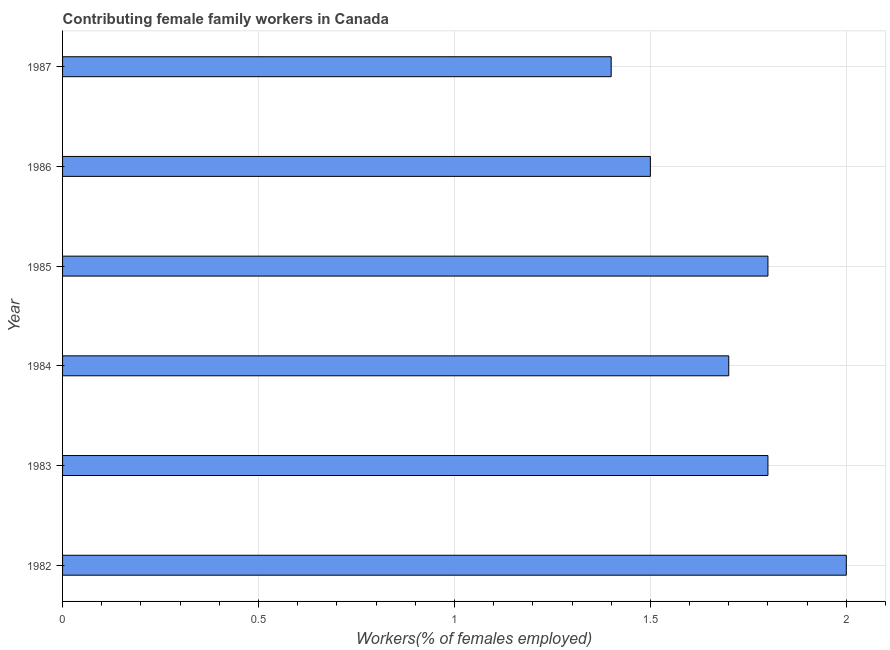Does the graph contain any zero values?
Your answer should be compact. No. What is the title of the graph?
Offer a very short reply. Contributing female family workers in Canada. What is the label or title of the X-axis?
Your answer should be compact. Workers(% of females employed). What is the contributing female family workers in 1983?
Your answer should be very brief. 1.8. Across all years, what is the maximum contributing female family workers?
Your answer should be compact. 2. Across all years, what is the minimum contributing female family workers?
Make the answer very short. 1.4. In which year was the contributing female family workers maximum?
Your answer should be compact. 1982. What is the sum of the contributing female family workers?
Ensure brevity in your answer.  10.2. What is the average contributing female family workers per year?
Offer a very short reply. 1.7. In how many years, is the contributing female family workers greater than 0.1 %?
Make the answer very short. 6. Do a majority of the years between 1984 and 1985 (inclusive) have contributing female family workers greater than 0.5 %?
Offer a terse response. Yes. What is the ratio of the contributing female family workers in 1982 to that in 1984?
Offer a terse response. 1.18. What is the difference between the highest and the second highest contributing female family workers?
Provide a short and direct response. 0.2. In how many years, is the contributing female family workers greater than the average contributing female family workers taken over all years?
Provide a short and direct response. 4. How many bars are there?
Your answer should be very brief. 6. What is the Workers(% of females employed) of 1982?
Your answer should be compact. 2. What is the Workers(% of females employed) in 1983?
Give a very brief answer. 1.8. What is the Workers(% of females employed) of 1984?
Offer a terse response. 1.7. What is the Workers(% of females employed) of 1985?
Offer a terse response. 1.8. What is the Workers(% of females employed) of 1986?
Provide a short and direct response. 1.5. What is the Workers(% of females employed) in 1987?
Your response must be concise. 1.4. What is the difference between the Workers(% of females employed) in 1982 and 1984?
Offer a very short reply. 0.3. What is the difference between the Workers(% of females employed) in 1982 and 1985?
Your answer should be compact. 0.2. What is the difference between the Workers(% of females employed) in 1982 and 1986?
Ensure brevity in your answer.  0.5. What is the difference between the Workers(% of females employed) in 1982 and 1987?
Your response must be concise. 0.6. What is the difference between the Workers(% of females employed) in 1983 and 1985?
Give a very brief answer. 0. What is the difference between the Workers(% of females employed) in 1983 and 1986?
Your response must be concise. 0.3. What is the difference between the Workers(% of females employed) in 1984 and 1987?
Provide a short and direct response. 0.3. What is the difference between the Workers(% of females employed) in 1985 and 1986?
Make the answer very short. 0.3. What is the ratio of the Workers(% of females employed) in 1982 to that in 1983?
Your response must be concise. 1.11. What is the ratio of the Workers(% of females employed) in 1982 to that in 1984?
Offer a terse response. 1.18. What is the ratio of the Workers(% of females employed) in 1982 to that in 1985?
Make the answer very short. 1.11. What is the ratio of the Workers(% of females employed) in 1982 to that in 1986?
Ensure brevity in your answer.  1.33. What is the ratio of the Workers(% of females employed) in 1982 to that in 1987?
Your answer should be very brief. 1.43. What is the ratio of the Workers(% of females employed) in 1983 to that in 1984?
Make the answer very short. 1.06. What is the ratio of the Workers(% of females employed) in 1983 to that in 1985?
Provide a succinct answer. 1. What is the ratio of the Workers(% of females employed) in 1983 to that in 1987?
Ensure brevity in your answer.  1.29. What is the ratio of the Workers(% of females employed) in 1984 to that in 1985?
Ensure brevity in your answer.  0.94. What is the ratio of the Workers(% of females employed) in 1984 to that in 1986?
Offer a terse response. 1.13. What is the ratio of the Workers(% of females employed) in 1984 to that in 1987?
Make the answer very short. 1.21. What is the ratio of the Workers(% of females employed) in 1985 to that in 1987?
Provide a short and direct response. 1.29. What is the ratio of the Workers(% of females employed) in 1986 to that in 1987?
Provide a short and direct response. 1.07. 